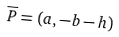<formula> <loc_0><loc_0><loc_500><loc_500>\overline { P } = ( a , - b - h )</formula> 